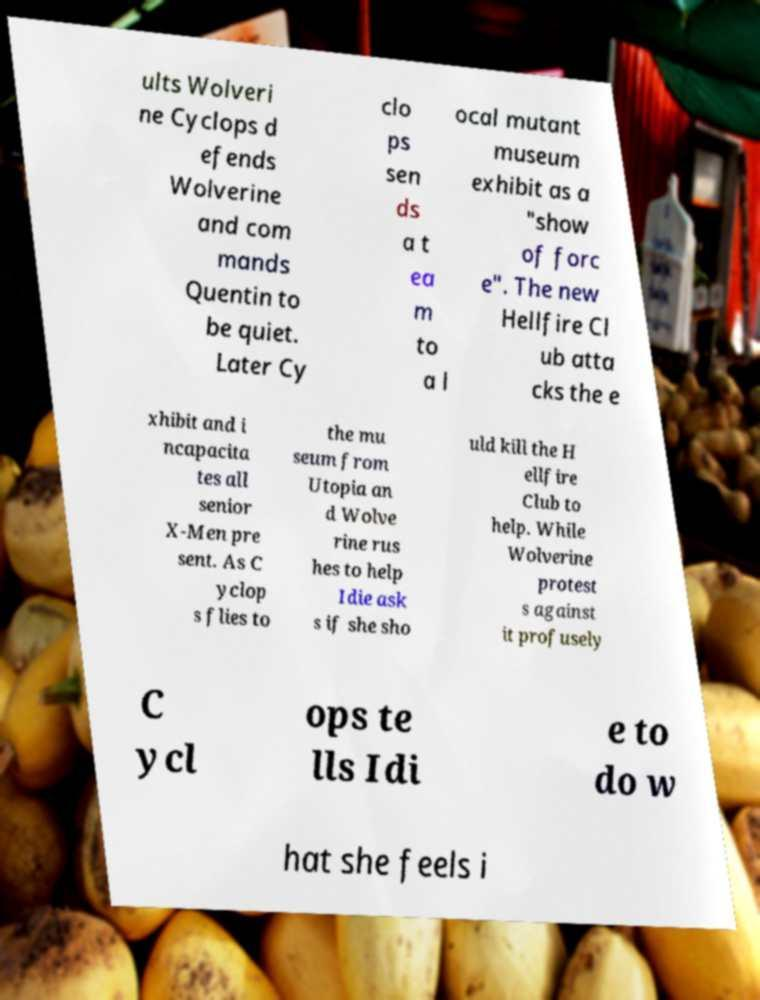There's text embedded in this image that I need extracted. Can you transcribe it verbatim? ults Wolveri ne Cyclops d efends Wolverine and com mands Quentin to be quiet. Later Cy clo ps sen ds a t ea m to a l ocal mutant museum exhibit as a "show of forc e". The new Hellfire Cl ub atta cks the e xhibit and i ncapacita tes all senior X-Men pre sent. As C yclop s flies to the mu seum from Utopia an d Wolve rine rus hes to help Idie ask s if she sho uld kill the H ellfire Club to help. While Wolverine protest s against it profusely C ycl ops te lls Idi e to do w hat she feels i 